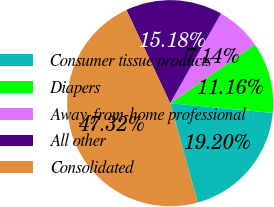Convert chart. <chart><loc_0><loc_0><loc_500><loc_500><pie_chart><fcel>Consumer tissue products<fcel>Diapers<fcel>Away-from-home professional<fcel>All other<fcel>Consolidated<nl><fcel>19.2%<fcel>11.16%<fcel>7.14%<fcel>15.18%<fcel>47.32%<nl></chart> 